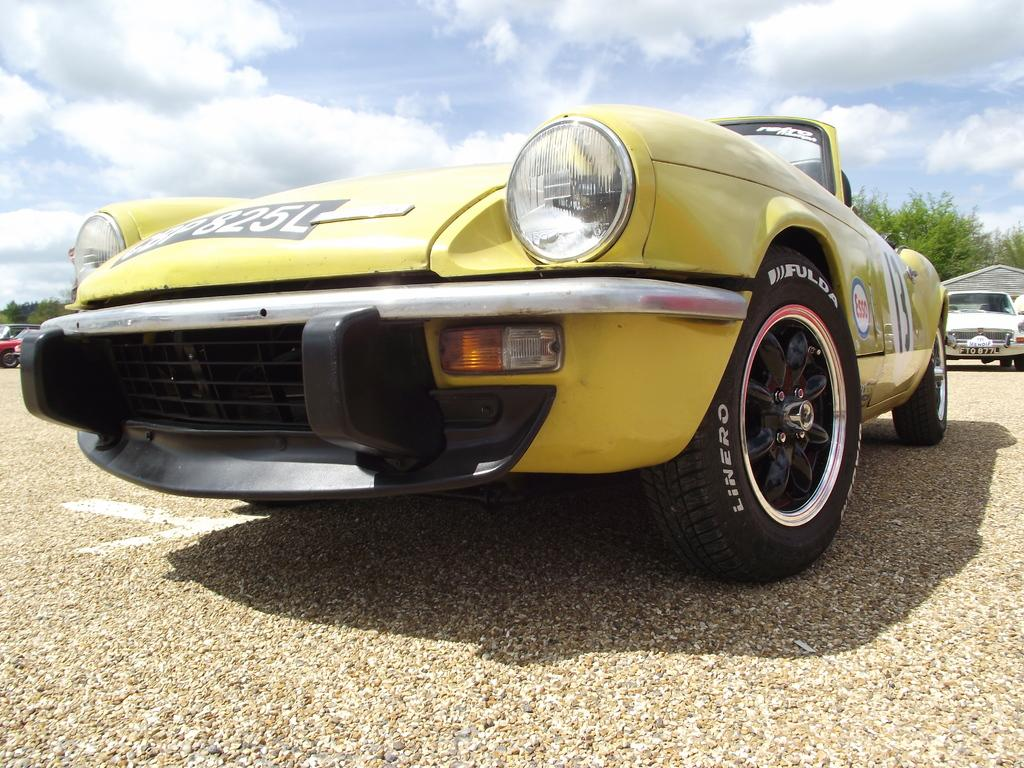What type of vehicles can be seen in the image? There are cars in the image. What other elements are present in the image besides cars? There are trees, shadows, clouds, and the sky visible in the image. Can you describe the writing on at least one car in the image? Yes, there is writing on at least one car in the image. What is the condition of the sky in the image? The sky is visible in the image, and clouds are present. What type of yarn is being used to create the clouds in the image? There is no yarn present in the image; the clouds are natural formations in the sky. How does the size of the trees in the image compare to the size of the cars? The size of the trees and cars cannot be compared directly in the image, as they are not depicted at the same scale. 